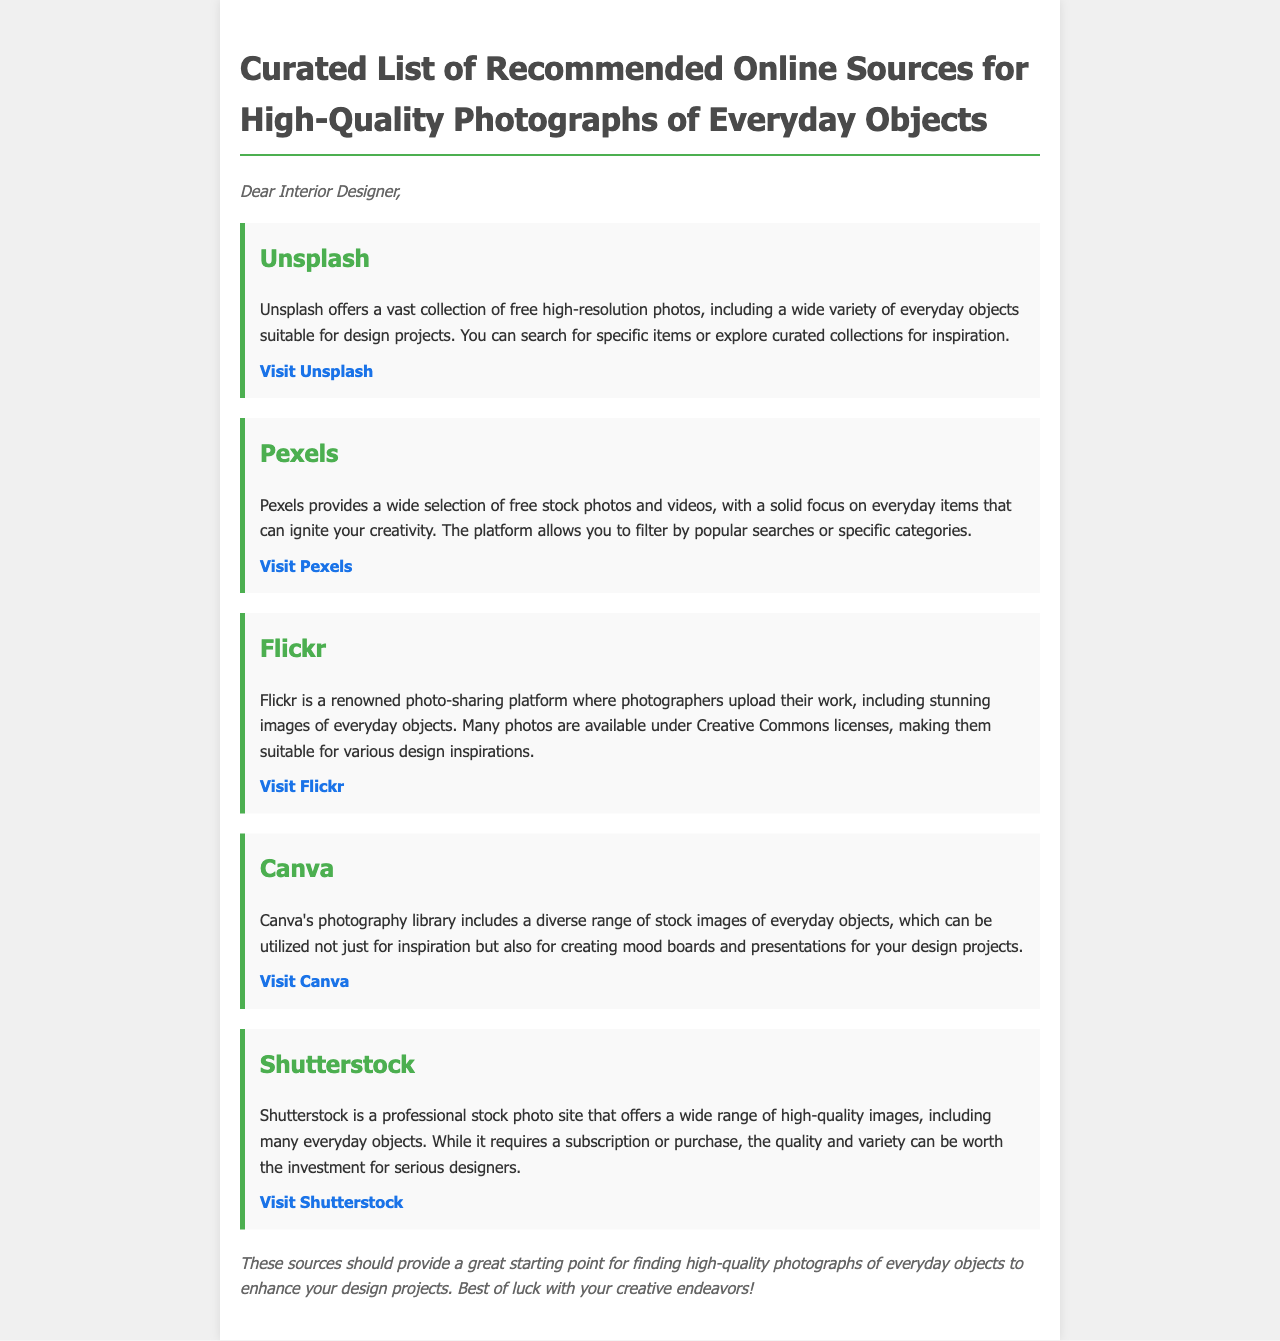What is the title of the document? The title is given in the header and describes the content of the document.
Answer: Curated List of Recommended Online Sources for High-Quality Photographs of Everyday Objects How many online sources are recommended in the document? Each source is listed separately in the document, and they can be counted.
Answer: Five What is the first online source mentioned? The first source is listed at the beginning of the sources section.
Answer: Unsplash Which platform allows filtering by popular searches? The document states certain features of the online sources, including filtering options.
Answer: Pexels What type of license do many Flickr photos have? The document specifies the licensing information for photos shared on Flickr.
Answer: Creative Commons What can Canva's photography library be used for besides inspiration? The document mentions additional uses for images found on Canva.
Answer: Creating mood boards Is Shutterstock a free source? The document discusses the cost associated with Shutterstock.
Answer: No What color highlights the source titles? The document provides information on the visual style used for source titles.
Answer: Green 